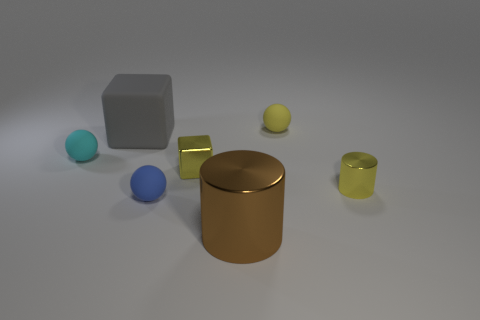Add 1 big shiny cubes. How many objects exist? 8 Subtract all blue balls. How many balls are left? 2 Subtract all balls. How many objects are left? 4 Subtract 1 yellow cylinders. How many objects are left? 6 Subtract all green balls. Subtract all purple cylinders. How many balls are left? 3 Subtract all large blue balls. Subtract all gray objects. How many objects are left? 6 Add 1 brown metallic cylinders. How many brown metallic cylinders are left? 2 Add 3 tiny spheres. How many tiny spheres exist? 6 